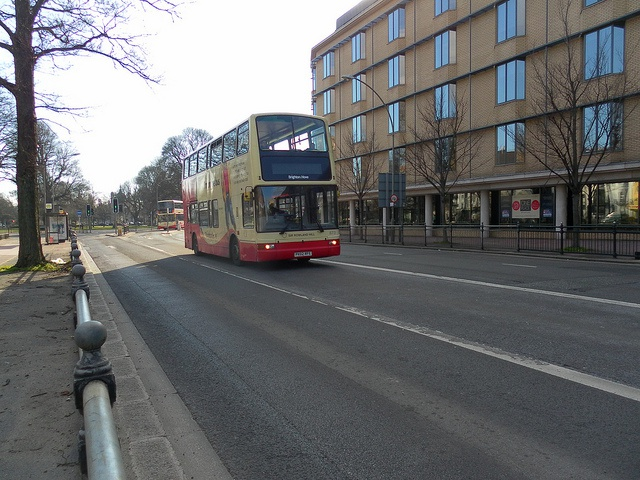Describe the objects in this image and their specific colors. I can see bus in white, gray, black, and navy tones, bus in white, gray, tan, and darkgray tones, traffic light in white, gray, black, and darkgray tones, traffic light in white, black, gray, and darkgreen tones, and traffic light in white, gray, and black tones in this image. 